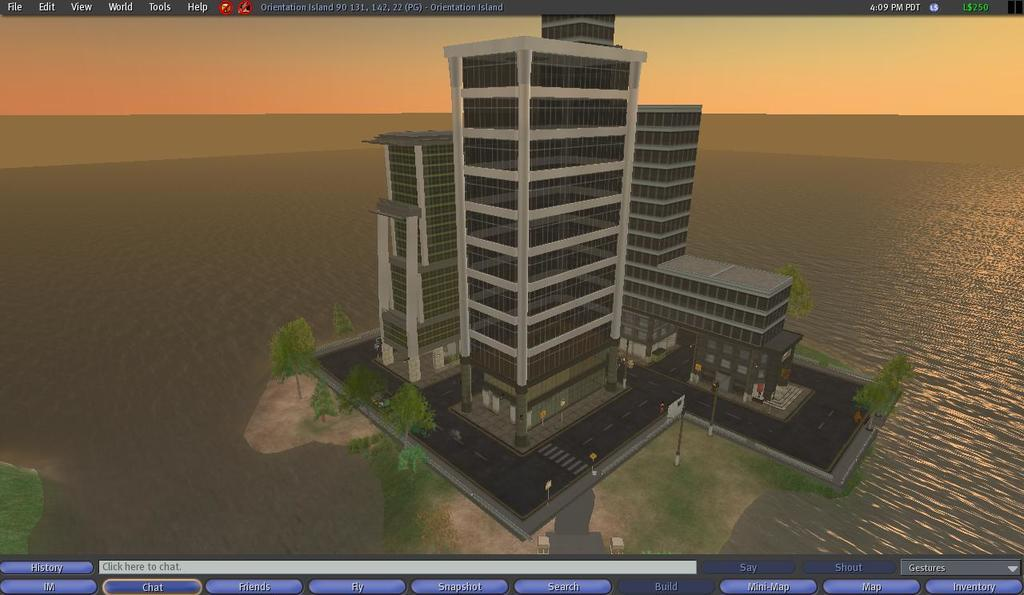What type of structure is depicted in the image? There is an animated building in the image. Where is the building located in relation to other elements in the image? The building is on a path. What natural element can be seen in the image? There is water visible in the image. What part of the natural environment is visible in the image? The sky is visible in the image. How many trucks are parked near the animated building in the image? There are no trucks present in the image. 